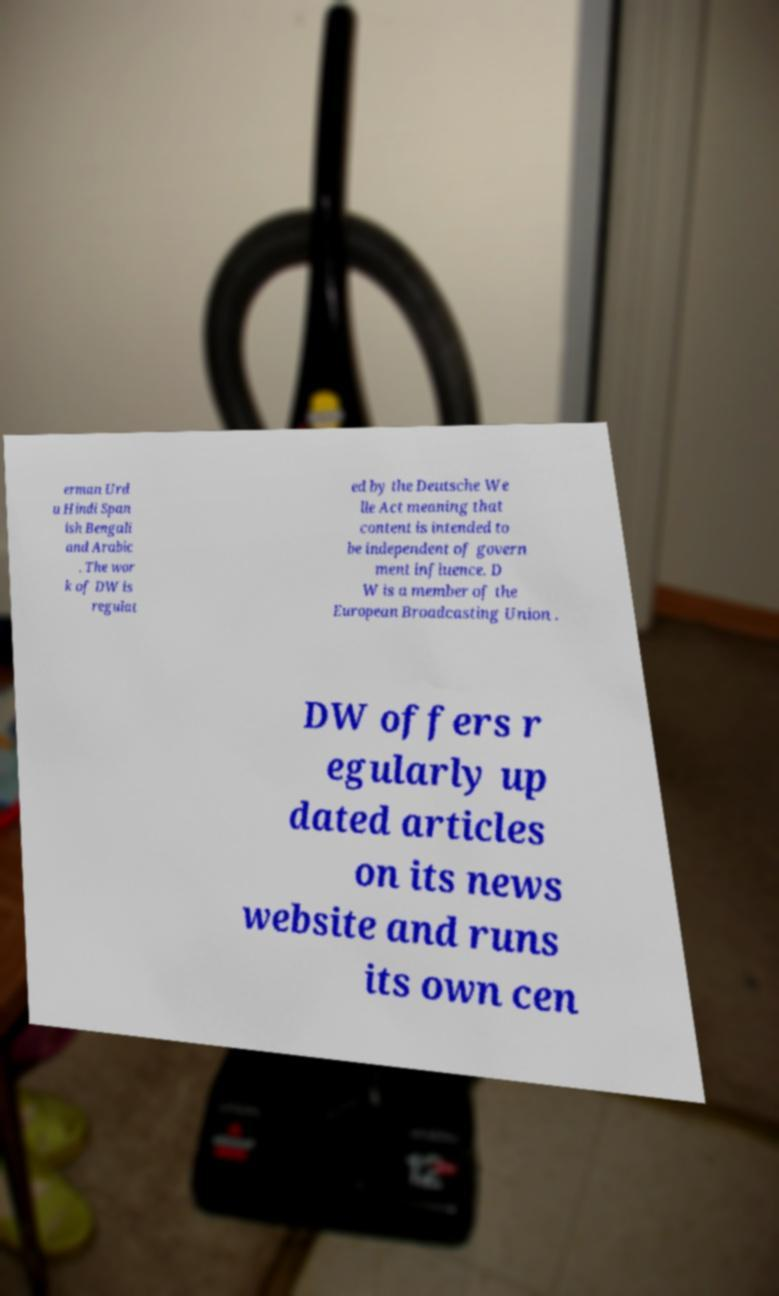Please identify and transcribe the text found in this image. erman Urd u Hindi Span ish Bengali and Arabic . The wor k of DW is regulat ed by the Deutsche We lle Act meaning that content is intended to be independent of govern ment influence. D W is a member of the European Broadcasting Union . DW offers r egularly up dated articles on its news website and runs its own cen 